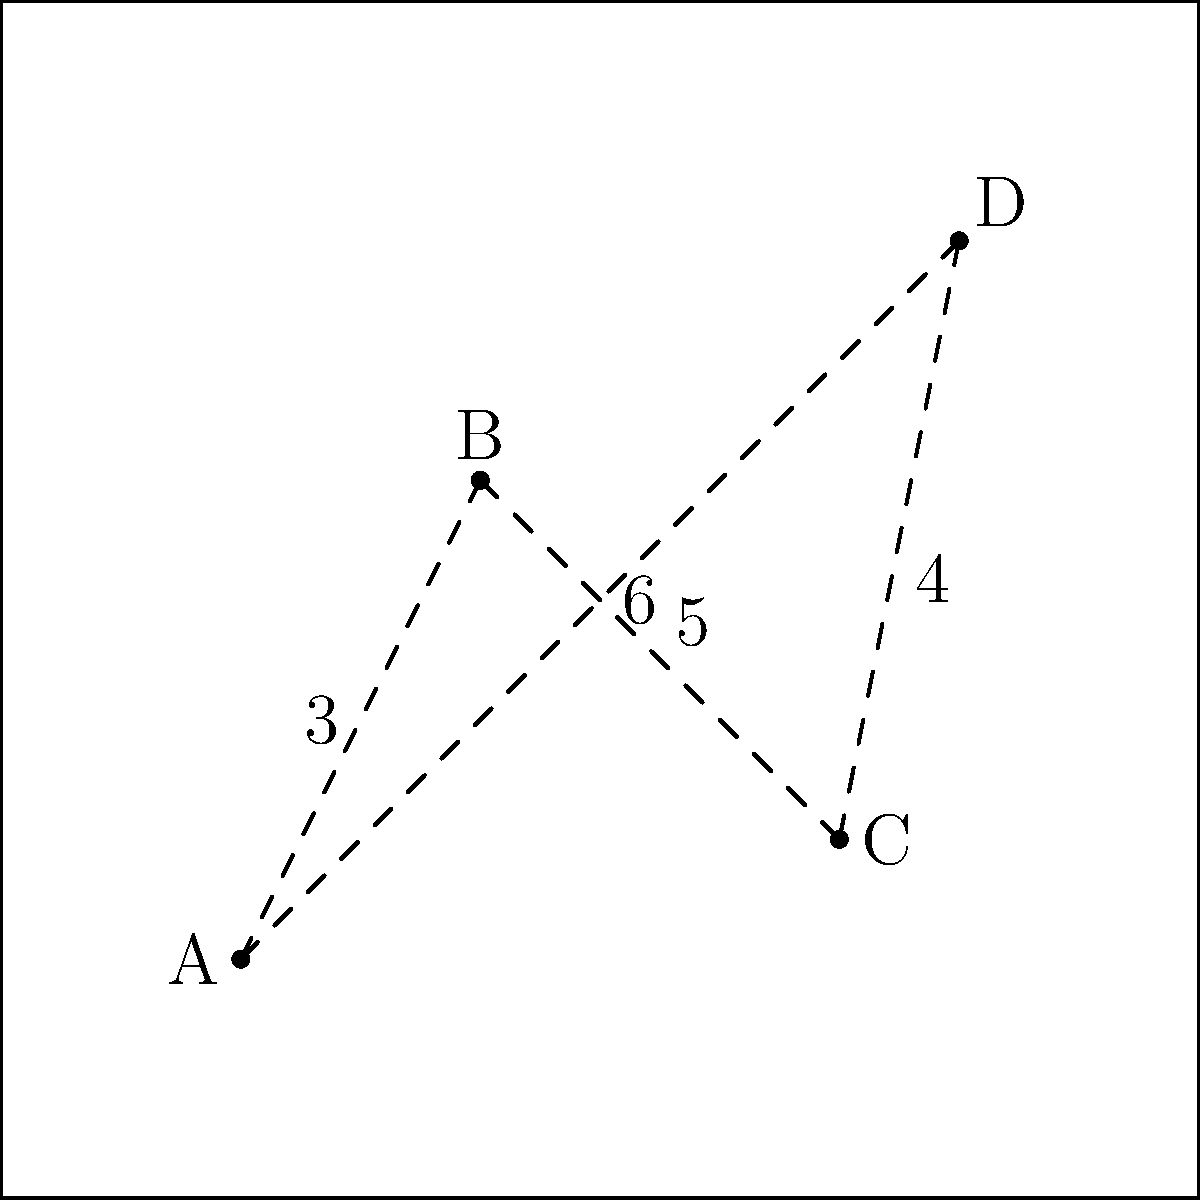Given the farm layout for the harvest festival, where activities A, B, C, and D are placed as shown, what is the optimal order to visit all activities while minimizing the total walking distance? Assume the festival starts and ends at activity A. To find the optimal order to visit all activities while minimizing the total walking distance, we need to solve the Traveling Salesman Problem (TSP) for this specific case. Here's how we can approach it:

1. Identify all possible routes:
   - A → B → C → D → A
   - A → B → D → C → A
   - A → C → B → D → A
   - A → C → D → B → A
   - A → D → B → C → A
   - A → D → C → B → A

2. Calculate the total distance for each route:
   - A → B → C → D → A: 3 + 5 + 4 + 6 = 18
   - A → B → D → C → A: 3 + 7 + 4 + 5 = 19
   - A → C → B → D → A: 5 + 5 + 7 + 6 = 23
   - A → C → D → B → A: 5 + 4 + 7 + 3 = 19
   - A → D → B → C → A: 6 + 7 + 5 + 5 = 23
   - A → D → C → B → A: 6 + 4 + 5 + 3 = 18

3. Compare the total distances:
   The routes with the shortest total distance are:
   - A → B → C → D → A (18 units)
   - A → D → C → B → A (18 units)

4. Choose the optimal route:
   Both routes have the same total distance, so either can be considered optimal. For consistency, we'll choose the first one in alphabetical order.

Therefore, the optimal order to visit all activities while minimizing the total walking distance is A → B → C → D → A.
Answer: A → B → C → D → A 